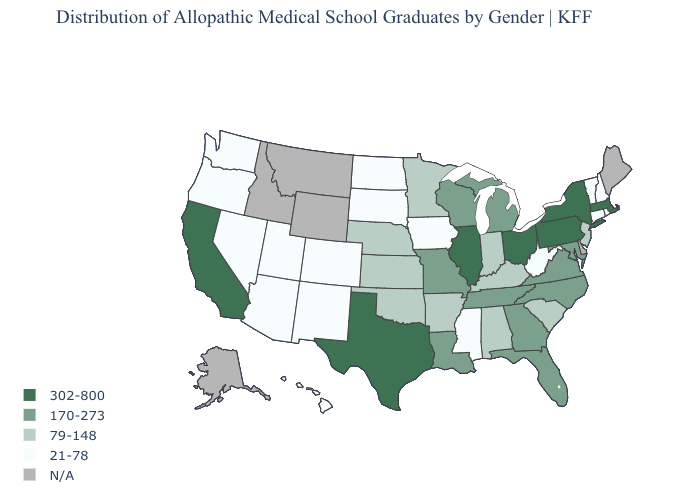Does the map have missing data?
Be succinct. Yes. Among the states that border Tennessee , which have the highest value?
Concise answer only. Georgia, Missouri, North Carolina, Virginia. Among the states that border Ohio , does Indiana have the lowest value?
Answer briefly. No. What is the value of Utah?
Be succinct. 21-78. Name the states that have a value in the range 170-273?
Write a very short answer. Florida, Georgia, Louisiana, Maryland, Michigan, Missouri, North Carolina, Tennessee, Virginia, Wisconsin. Does the map have missing data?
Be succinct. Yes. Name the states that have a value in the range 302-800?
Short answer required. California, Illinois, Massachusetts, New York, Ohio, Pennsylvania, Texas. Does the first symbol in the legend represent the smallest category?
Write a very short answer. No. Does North Dakota have the lowest value in the MidWest?
Short answer required. Yes. What is the value of Vermont?
Give a very brief answer. 21-78. What is the value of Washington?
Answer briefly. 21-78. Name the states that have a value in the range 79-148?
Answer briefly. Alabama, Arkansas, Indiana, Kansas, Kentucky, Minnesota, Nebraska, New Jersey, Oklahoma, South Carolina. Among the states that border Arizona , which have the highest value?
Short answer required. California. 